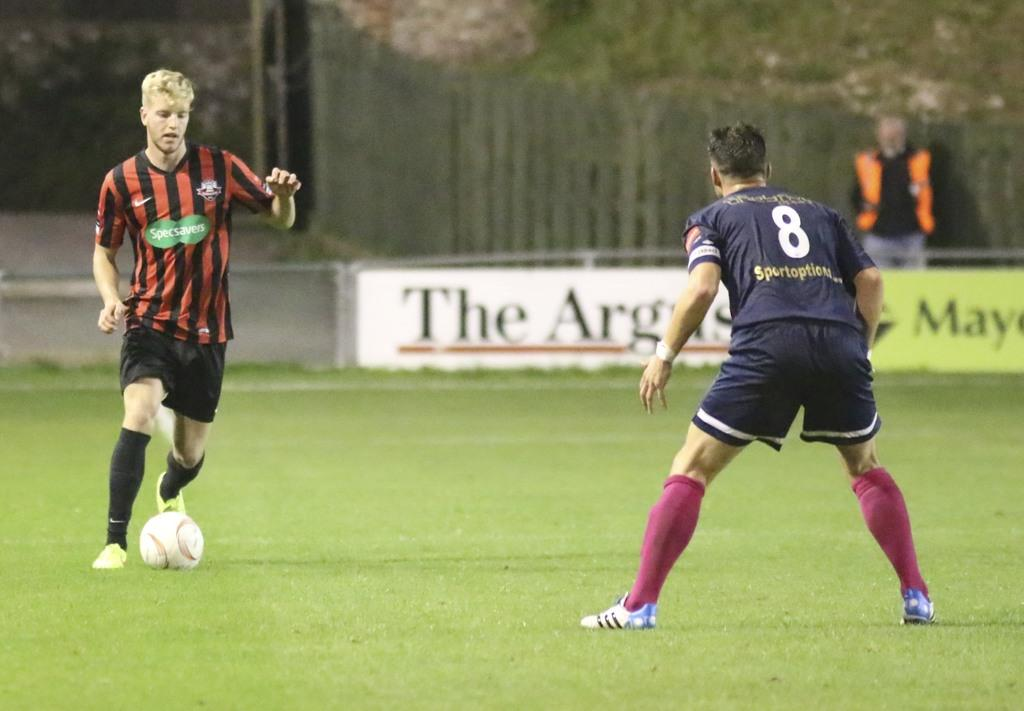<image>
Create a compact narrative representing the image presented. A player kicking the ball in a soccer match wears and advertisement for Specsavers on his jersey. 